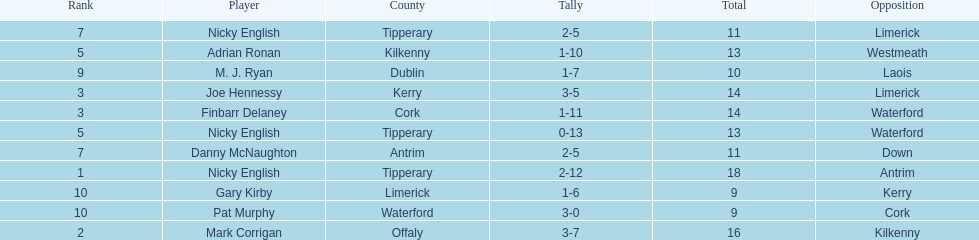Who ranked above mark corrigan? Nicky English. 